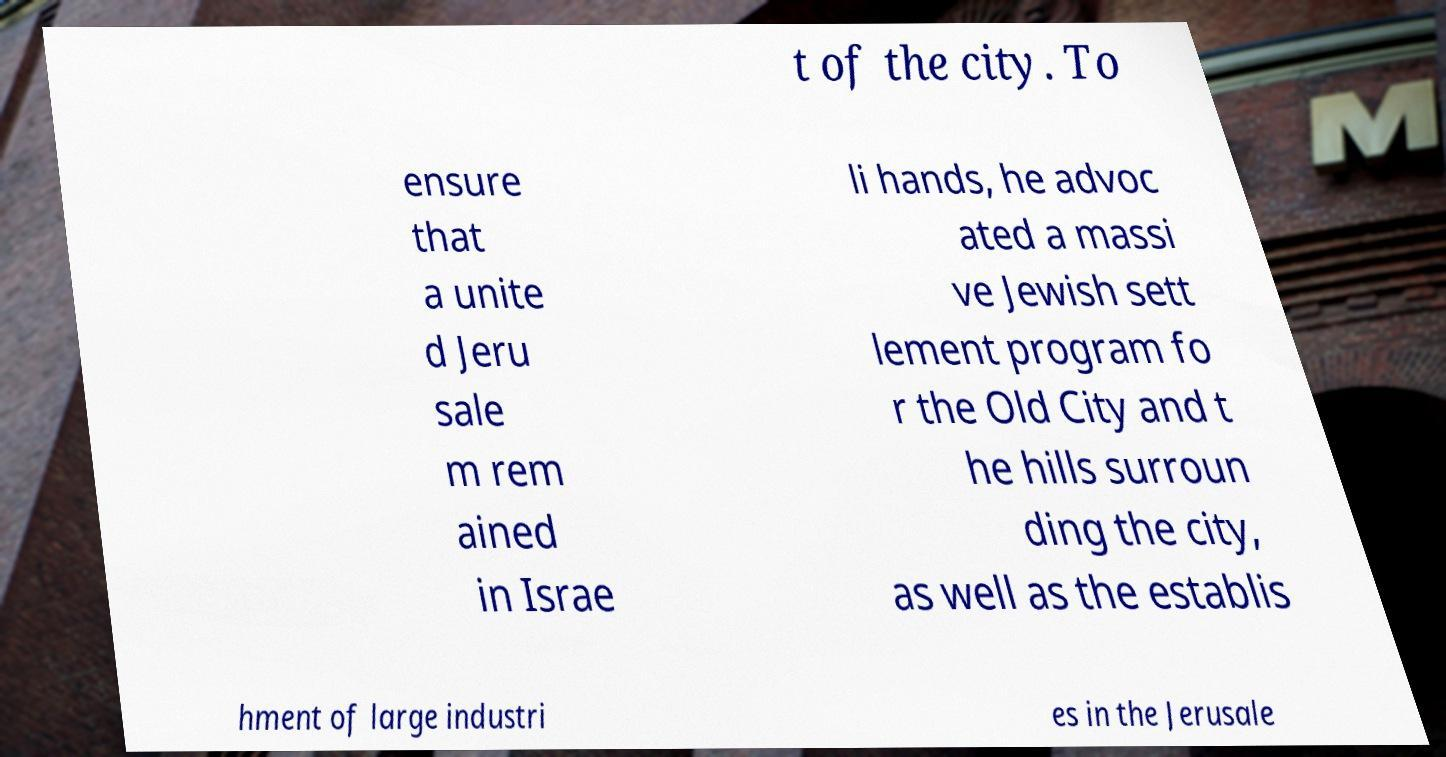For documentation purposes, I need the text within this image transcribed. Could you provide that? t of the city. To ensure that a unite d Jeru sale m rem ained in Israe li hands, he advoc ated a massi ve Jewish sett lement program fo r the Old City and t he hills surroun ding the city, as well as the establis hment of large industri es in the Jerusale 